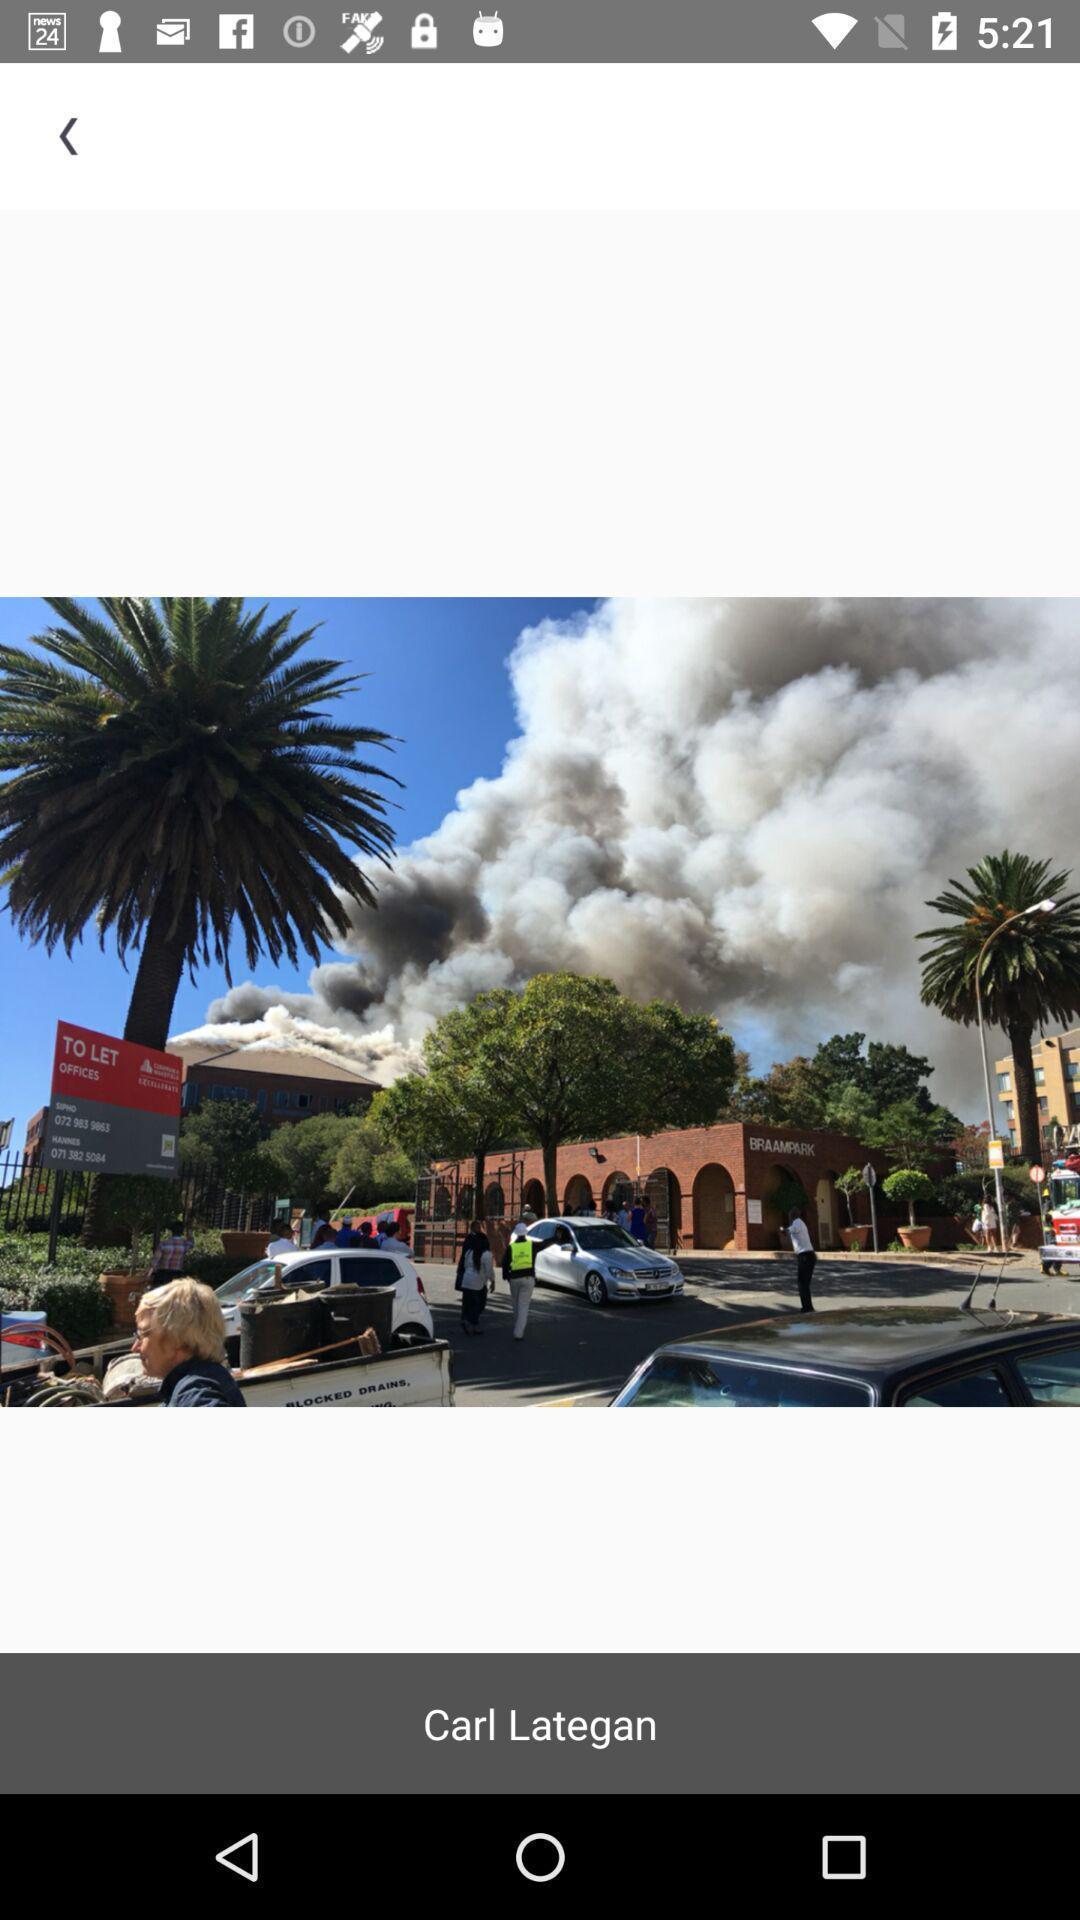Describe the content in this image. Page displaying the image of carl lategan. 